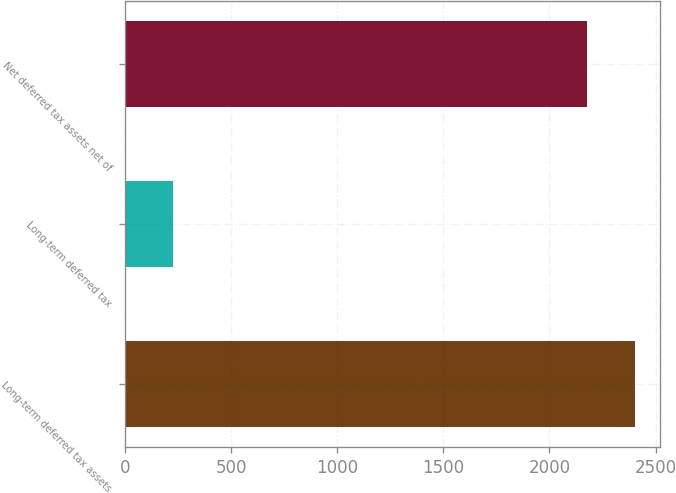Convert chart. <chart><loc_0><loc_0><loc_500><loc_500><bar_chart><fcel>Long-term deferred tax assets<fcel>Long-term deferred tax<fcel>Net deferred tax assets net of<nl><fcel>2403<fcel>228<fcel>2175<nl></chart> 